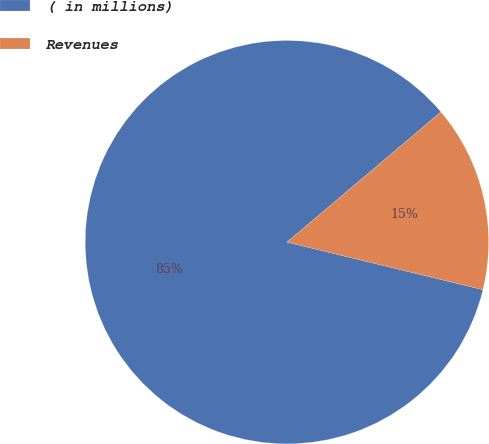Convert chart to OTSL. <chart><loc_0><loc_0><loc_500><loc_500><pie_chart><fcel>( in millions)<fcel>Revenues<nl><fcel>85.04%<fcel>14.96%<nl></chart> 